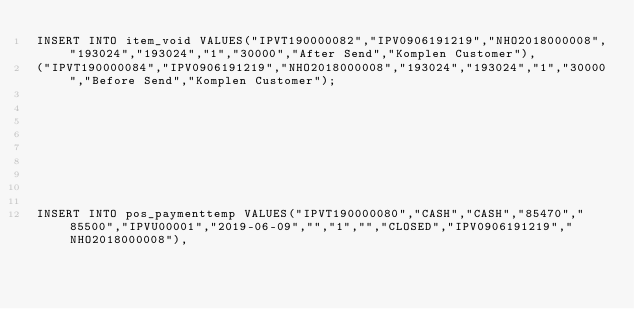<code> <loc_0><loc_0><loc_500><loc_500><_SQL_>INSERT INTO item_void VALUES("IPVT190000082","IPV0906191219","NHO2018000008","193024","193024","1","30000","After Send","Komplen Customer"),
("IPVT190000084","IPV0906191219","NHO2018000008","193024","193024","1","30000","Before Send","Komplen Customer");









INSERT INTO pos_paymenttemp VALUES("IPVT190000080","CASH","CASH","85470","85500","IPVU00001","2019-06-09","","1","","CLOSED","IPV0906191219","NHO2018000008"),</code> 